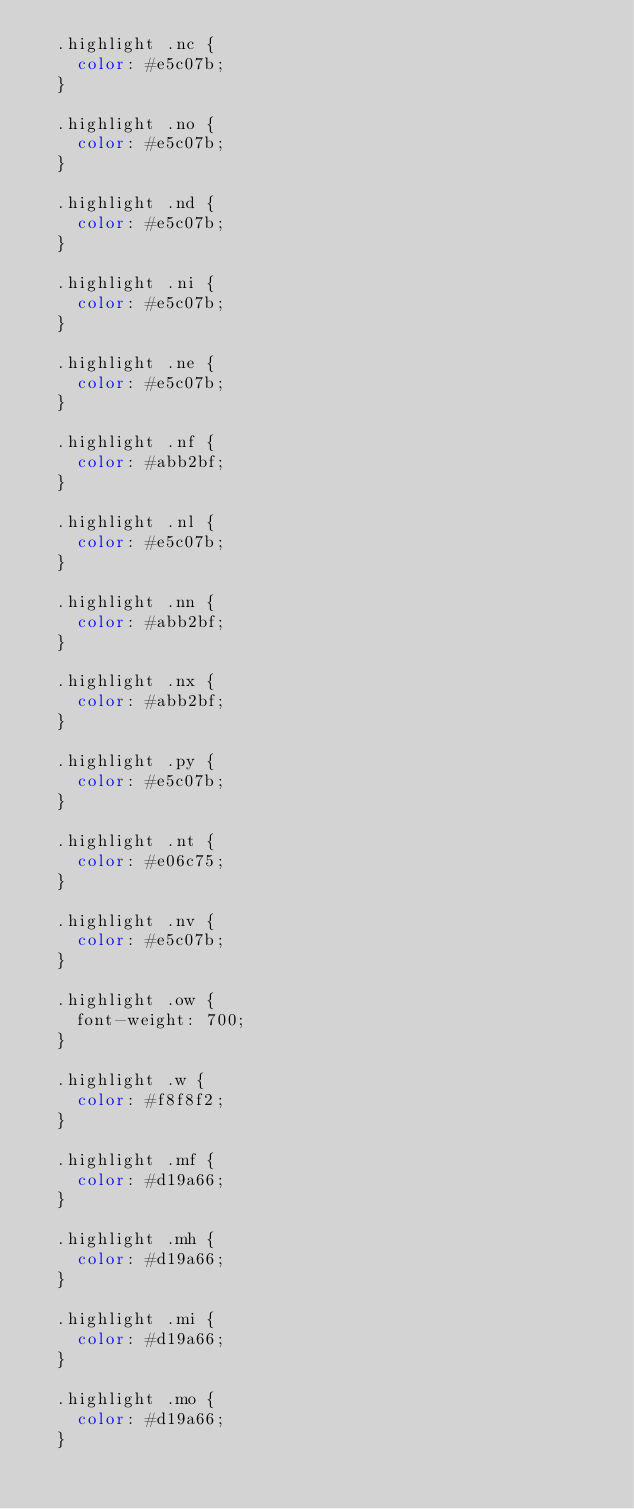Convert code to text. <code><loc_0><loc_0><loc_500><loc_500><_CSS_>  .highlight .nc {
    color: #e5c07b;
  }
  
  .highlight .no {
    color: #e5c07b;
  }
  
  .highlight .nd {
    color: #e5c07b;
  }
  
  .highlight .ni {
    color: #e5c07b;
  }
  
  .highlight .ne {
    color: #e5c07b;
  }
  
  .highlight .nf {
    color: #abb2bf;
  }
  
  .highlight .nl {
    color: #e5c07b;
  }
  
  .highlight .nn {
    color: #abb2bf;
  }
  
  .highlight .nx {
    color: #abb2bf;
  }
  
  .highlight .py {
    color: #e5c07b;
  }
  
  .highlight .nt {
    color: #e06c75;
  }
  
  .highlight .nv {
    color: #e5c07b;
  }
  
  .highlight .ow {
    font-weight: 700;
  }
  
  .highlight .w {
    color: #f8f8f2;
  }
  
  .highlight .mf {
    color: #d19a66;
  }
  
  .highlight .mh {
    color: #d19a66;
  }
  
  .highlight .mi {
    color: #d19a66;
  }
  
  .highlight .mo {
    color: #d19a66;
  }
  </code> 